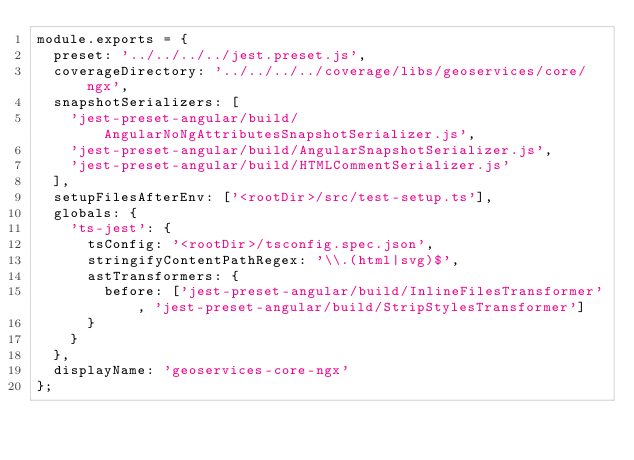Convert code to text. <code><loc_0><loc_0><loc_500><loc_500><_JavaScript_>module.exports = {
  preset: '../../../../jest.preset.js',
  coverageDirectory: '../../../../coverage/libs/geoservices/core/ngx',
  snapshotSerializers: [
    'jest-preset-angular/build/AngularNoNgAttributesSnapshotSerializer.js',
    'jest-preset-angular/build/AngularSnapshotSerializer.js',
    'jest-preset-angular/build/HTMLCommentSerializer.js'
  ],
  setupFilesAfterEnv: ['<rootDir>/src/test-setup.ts'],
  globals: {
    'ts-jest': {
      tsConfig: '<rootDir>/tsconfig.spec.json',
      stringifyContentPathRegex: '\\.(html|svg)$',
      astTransformers: {
        before: ['jest-preset-angular/build/InlineFilesTransformer', 'jest-preset-angular/build/StripStylesTransformer']
      }
    }
  },
  displayName: 'geoservices-core-ngx'
};
</code> 